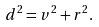<formula> <loc_0><loc_0><loc_500><loc_500>d ^ { 2 } = v ^ { 2 } + r ^ { 2 } .</formula> 